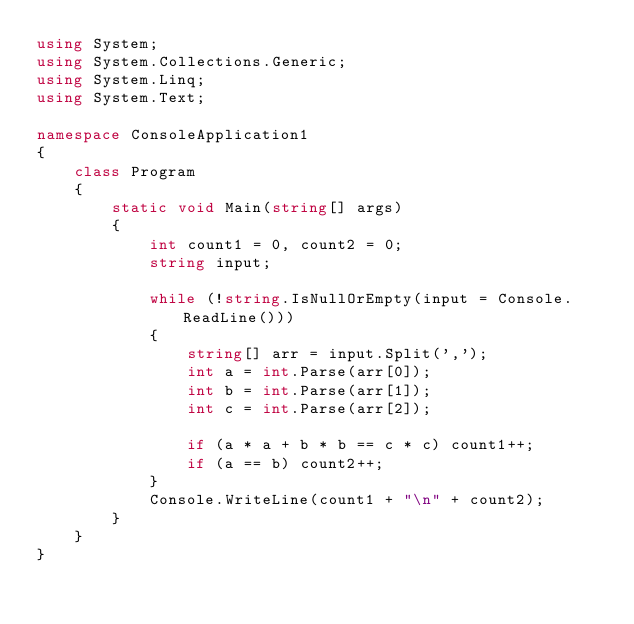<code> <loc_0><loc_0><loc_500><loc_500><_C#_>using System;
using System.Collections.Generic;
using System.Linq;
using System.Text;

namespace ConsoleApplication1
{
    class Program
    {
        static void Main(string[] args)
        {
            int count1 = 0, count2 = 0;
            string input;

            while (!string.IsNullOrEmpty(input = Console.ReadLine()))
            {
                string[] arr = input.Split(',');
                int a = int.Parse(arr[0]);
                int b = int.Parse(arr[1]);
                int c = int.Parse(arr[2]);

                if (a * a + b * b == c * c) count1++;
                if (a == b) count2++;
            }
            Console.WriteLine(count1 + "\n" + count2);
        }
    }
}</code> 